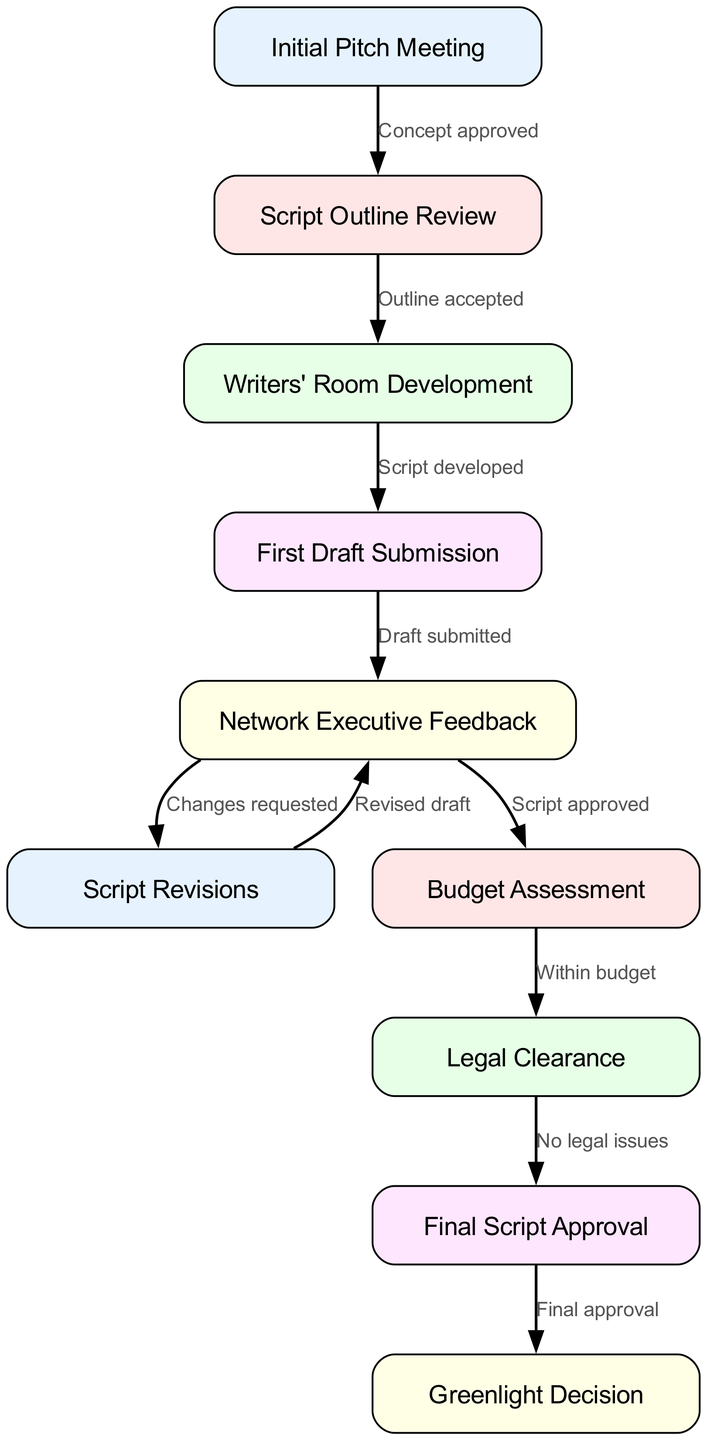What is the first step in the script approval process? The first step in the process is represented by the node labeled "Initial Pitch Meeting." This node is the starting point and is not preceded by any other node in the flowchart.
Answer: Initial Pitch Meeting How many nodes are there in the diagram? To determine the number of nodes, we count each unique node listed in the data, which totals ten distinct nodes in the flowchart.
Answer: 10 What is the relationship between "Network Executive Feedback" and "Script Revisions"? The relationship is defined by the edge that connects these two nodes, labeled "Changes requested." This indicates that feedback from the network executive can result in revisions to the script.
Answer: Changes requested What node comes after "Legal Clearance"? The node that comes after "Legal Clearance" is "Final Script Approval." It follows directly in the flowchart, indicating the sequence of steps leading to final approval.
Answer: Final Script Approval If the "Draft submitted" receives negative feedback, which node does the flow return to? If the "Draft submitted" receives negative feedback, the process flows back to "Script Revisions," as indicated by the edge that connects these nodes. This necessitates revisiting and modifying the script based on the feedback.
Answer: Script Revisions What is the final step before a greenlight decision? The final step before a greenlight decision is "Final Script Approval." This occurs after all necessary approvals and checks are completed, leading up to the final decision to proceed with production.
Answer: Final Script Approval How many edges represent a feedback loop in the diagram? The diagram shows one feedback loop represented by the edge from "Script Revisions" back to "Network Executive Feedback," indicating that changes can lead to re-evaluation. By counting that scenario, we note only this loop among the edges.
Answer: 1 Which step requires budget assessment? The step that requires budget assessment is "Budget Assessment." This clearly follows the approval of the script, showing a necessary evaluation of whether the project fits within financial constraints.
Answer: Budget Assessment What step must occur before the "Final Script Approval"? The step that must occur before "Final Script Approval" is "Legal Clearance." It ensures that all legal aspects are resolved before granting final approval for the script.
Answer: Legal Clearance 